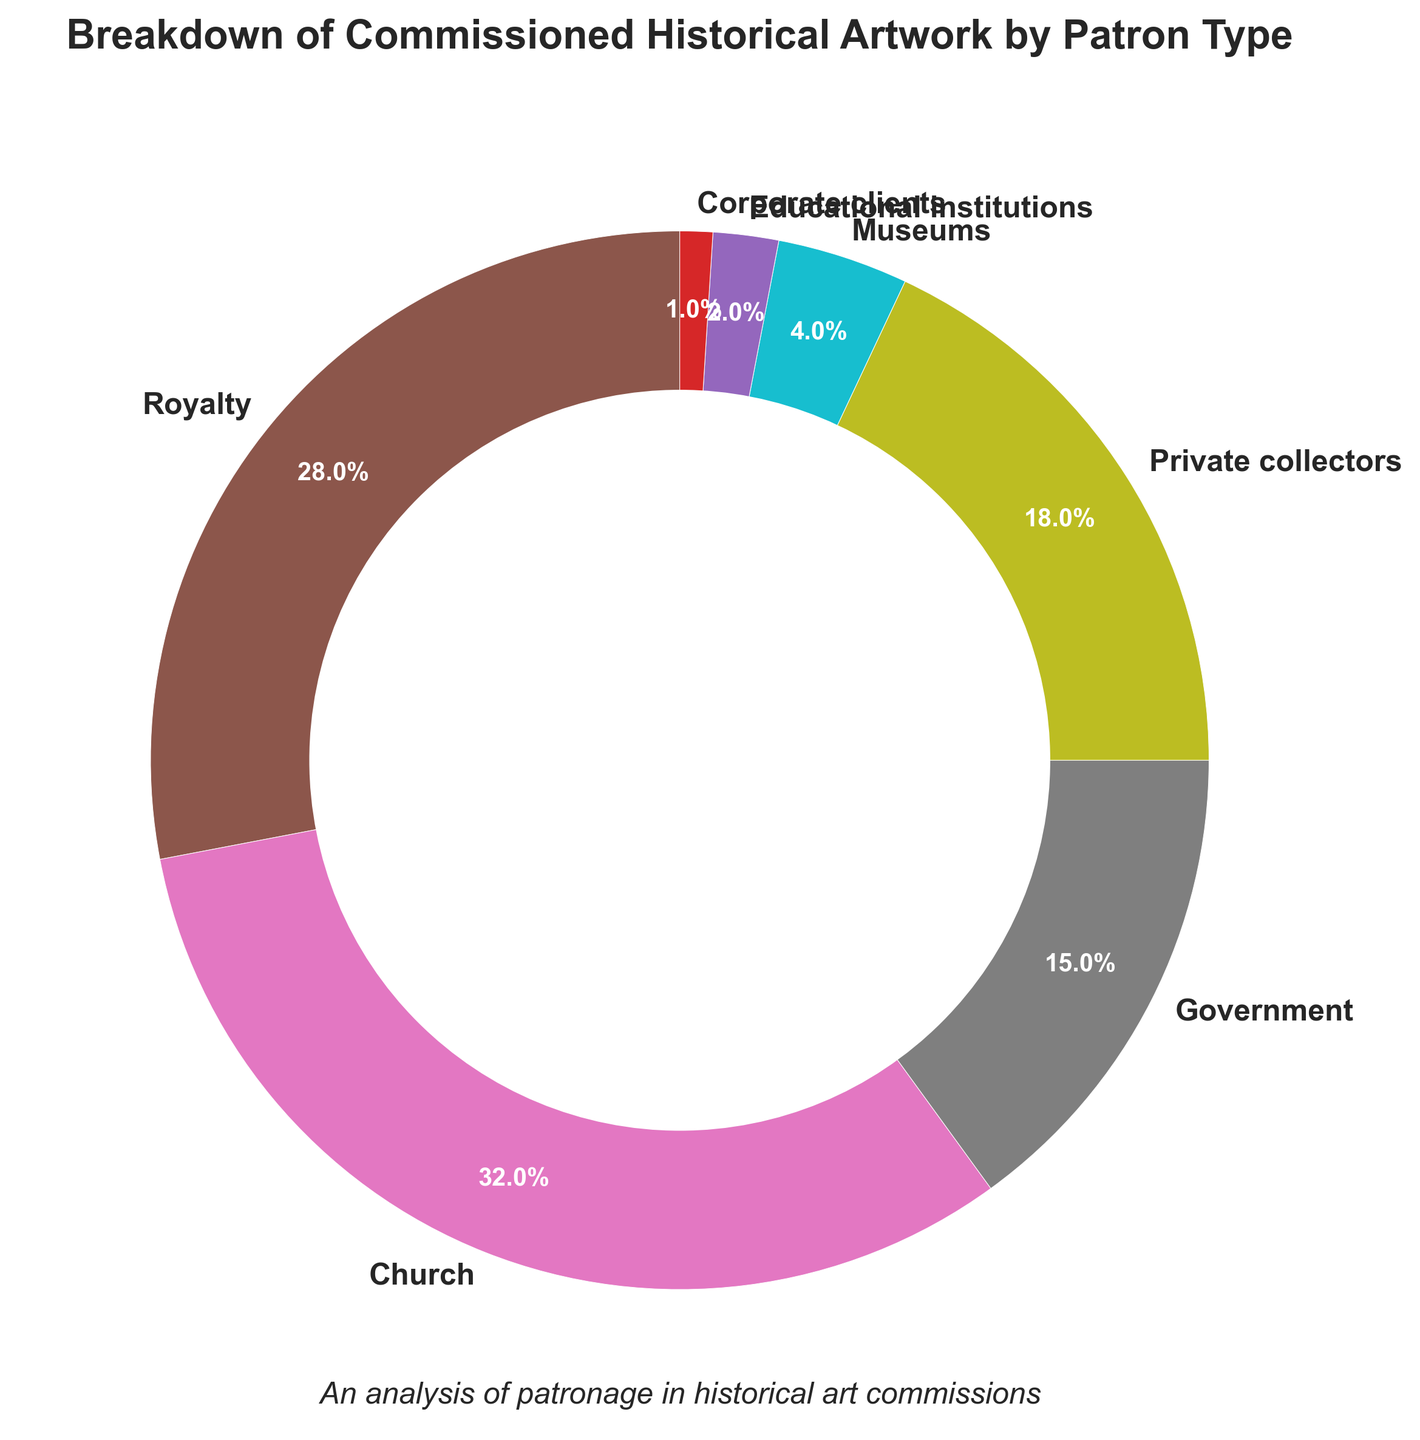Which two patron types contribute the most to commissioned historical artwork? The percentages of each patron type are: Royalty (28%), Church (32%), Government (15%), Private collectors (18%), Museums (4%), Educational institutions (2%), and Corporate clients (1%). The two highest percentages are from the Church (32%) and Royalty (28%).
Answer: Church and Royalty What is the combined percentage of contributions from Private collectors and Museums? The percentage for Private collectors is 18% and for Museums is 4%. Adding these together gives 18% + 4% = 22%.
Answer: 22% Which patron type has lesser contributions: Royalty or Government? The breakdown shows Royalty at 28% and Government at 15%. 15% is less than 28%.
Answer: Government What percentage of contributions do Corporate clients and Educational institutions make together? Corporate clients contribute 1% and Educational institutions contribute 2%. Adding these together gives 1% + 2% = 3%.
Answer: 3% If the artwork commissions from Government patrons doubled, what would their new percentage contribution be? The current percentage for Government is 15%. Doubling this amount would be 15% * 2 = 30%.
Answer: 30% Which slice of the pie chart is represented by a purple color? The purple color in the pie chart corresponds to Educational institutions.
Answer: Educational institutions How much greater is the Church's contribution compared to the Government's? The Church's contribution is 32% and the Government's is 15%. The difference is 32% - 15% = 17%.
Answer: 17% What is the combined contribution percentage of all patrons except the Church? The total percentage for all patron types is 100%. The Church's contribution is 32%. Subtracting this from the total gives 100% - 32% = 68%.
Answer: 68% What is the average contribution percentage of the Royalty, Government, and Private collectors? Adding the contributions of Royalty (28%), Government (15%), and Private collectors (18%) and then dividing by 3: (28% + 15% + 18%) / 3 = 61% / 3 = 20.33%.
Answer: 20.33% What two patron types combined contribute nearly half of the total percentage? Looking at the percentages, Royalty (28%) and Church (32%) together contribute 28% + 32% = 60%, which is more than half. The two patron types close to half are Private collectors (18%) and Royalty (28%), contributing 18% + 28% = 46%, which is nearly half.
Answer: Private collectors and Royalty 